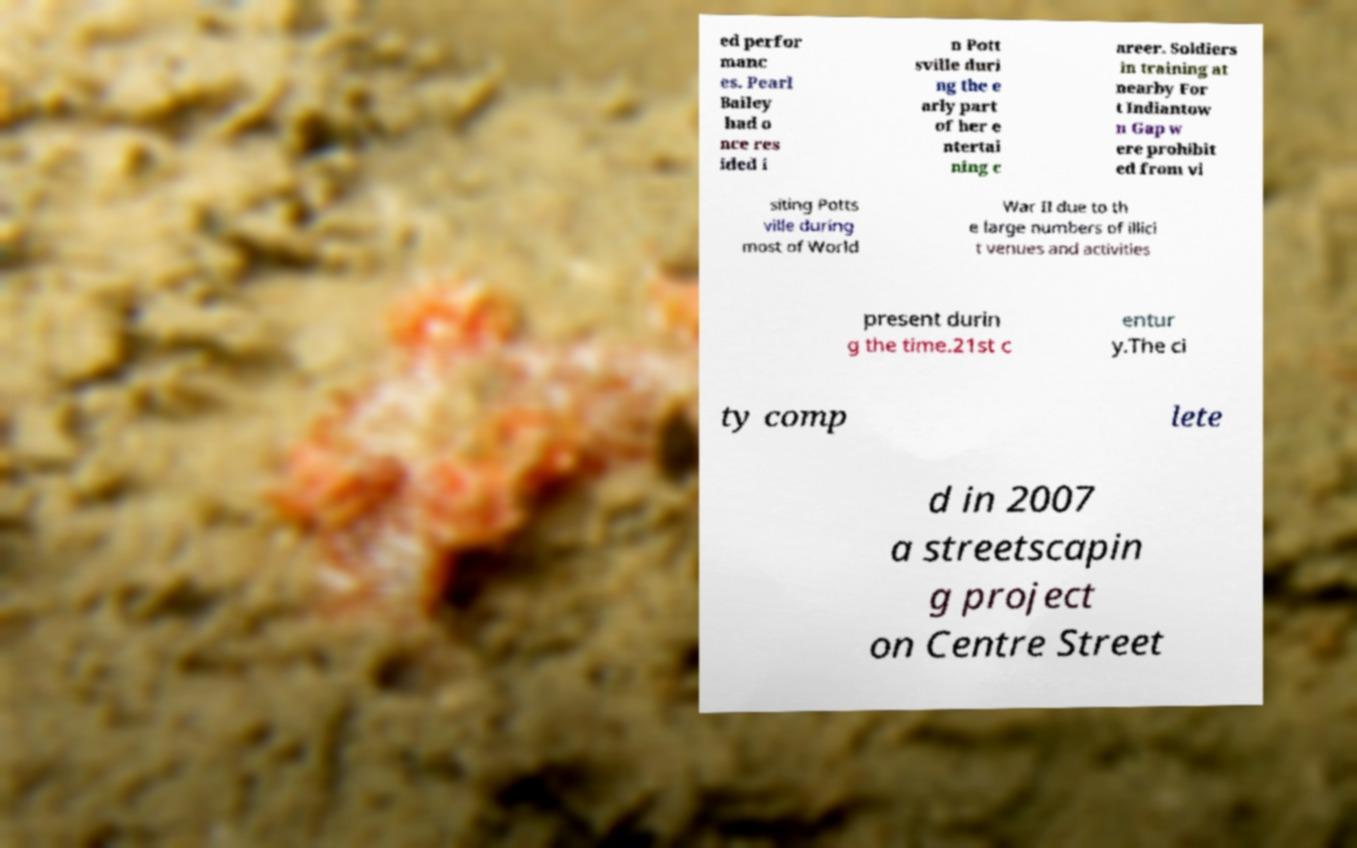Please identify and transcribe the text found in this image. ed perfor manc es. Pearl Bailey had o nce res ided i n Pott sville duri ng the e arly part of her e ntertai ning c areer. Soldiers in training at nearby For t Indiantow n Gap w ere prohibit ed from vi siting Potts ville during most of World War II due to th e large numbers of illici t venues and activities present durin g the time.21st c entur y.The ci ty comp lete d in 2007 a streetscapin g project on Centre Street 